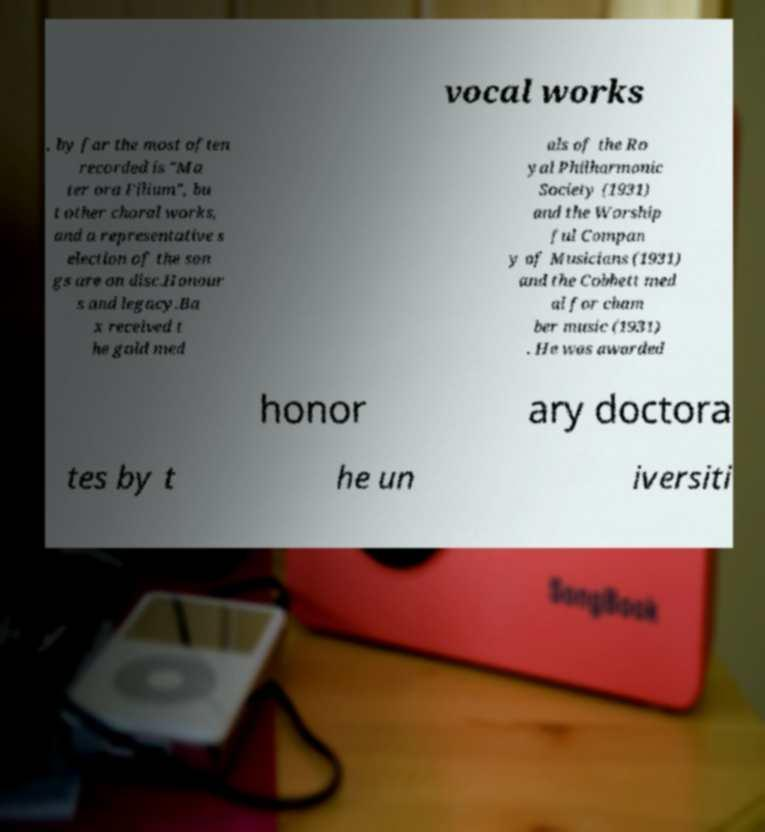For documentation purposes, I need the text within this image transcribed. Could you provide that? vocal works , by far the most often recorded is "Ma ter ora Filium", bu t other choral works, and a representative s election of the son gs are on disc.Honour s and legacy.Ba x received t he gold med als of the Ro yal Philharmonic Society (1931) and the Worship ful Compan y of Musicians (1931) and the Cobbett med al for cham ber music (1931) . He was awarded honor ary doctora tes by t he un iversiti 